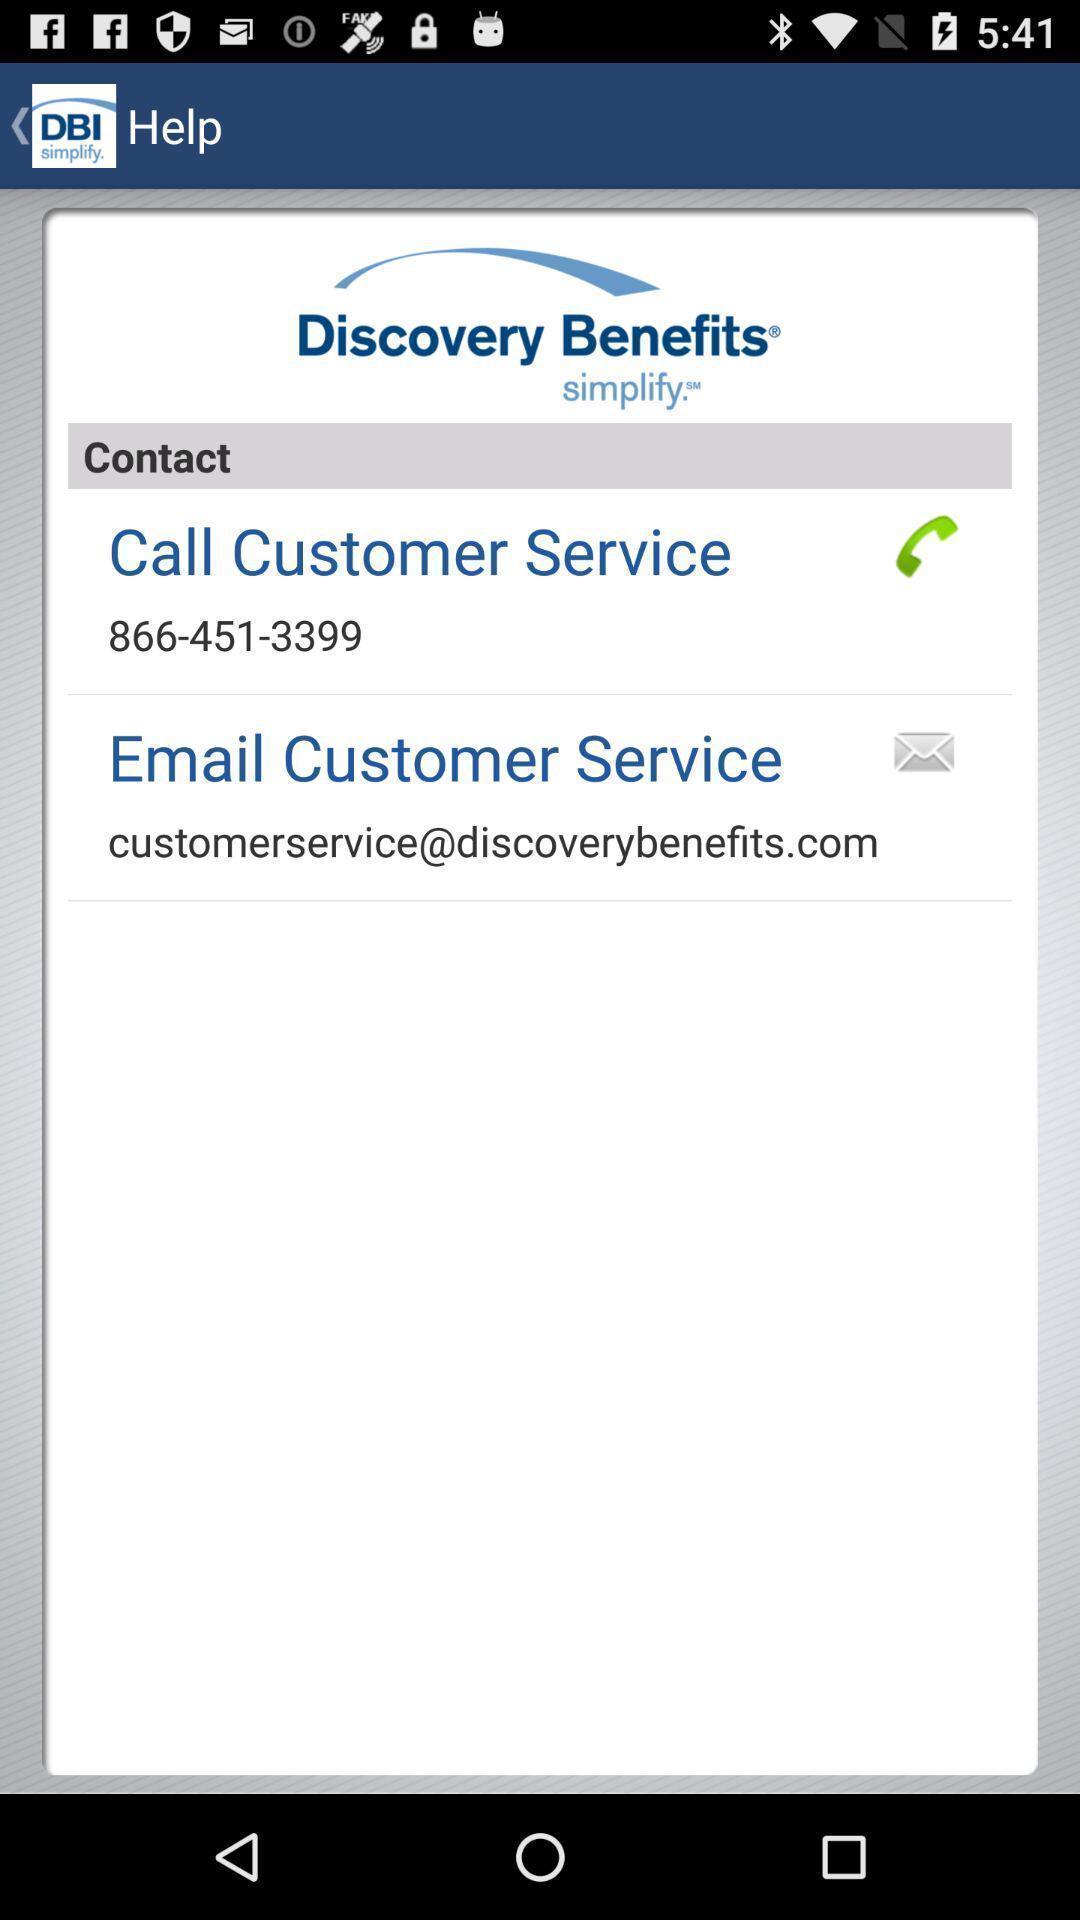Describe the content in this image. Pop up showing contact of customer care. 